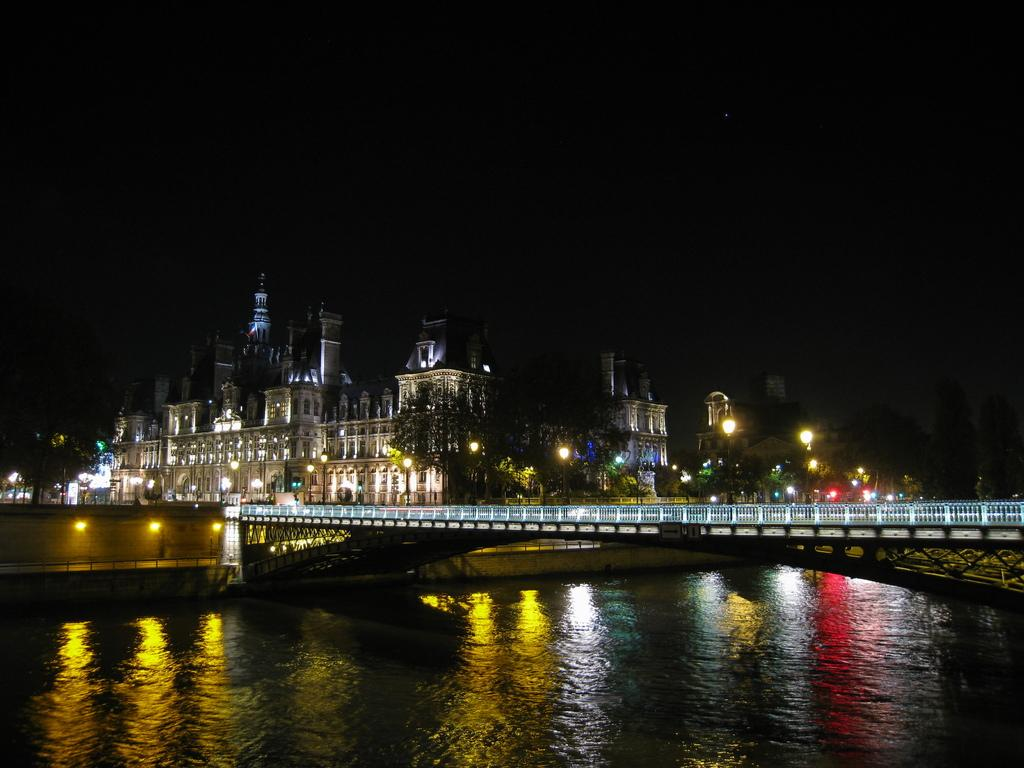What is the main feature of the image? There is water in the image. What structure is present over the water? There is a bridge in the image. What safety feature is present on the bridge? The bridge has railing. What can be seen illuminated in the image? There are lights visible in the image. What type of man-made structures are present in the image? There are buildings in the image. What is the appearance of the sky in the background? The sky in the background is dark. What type of sweater is being worn by the water in the image? There is no sweater present in the image, as the water is not a person or an object that can wear clothing. Can you hear the sound of sand in the image? There is no sand present in the image, so it is not possible to hear its sound. 